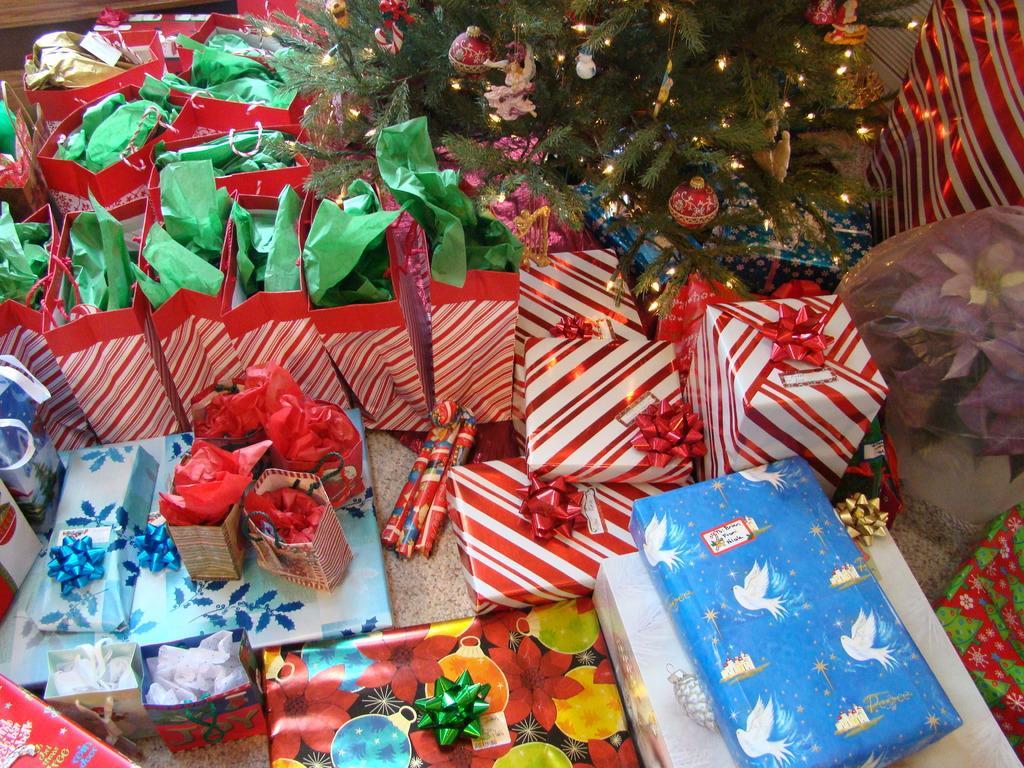Can you describe this image briefly? In this picture there are gift packs and there is a christmas tree and on the tree there are lights. 